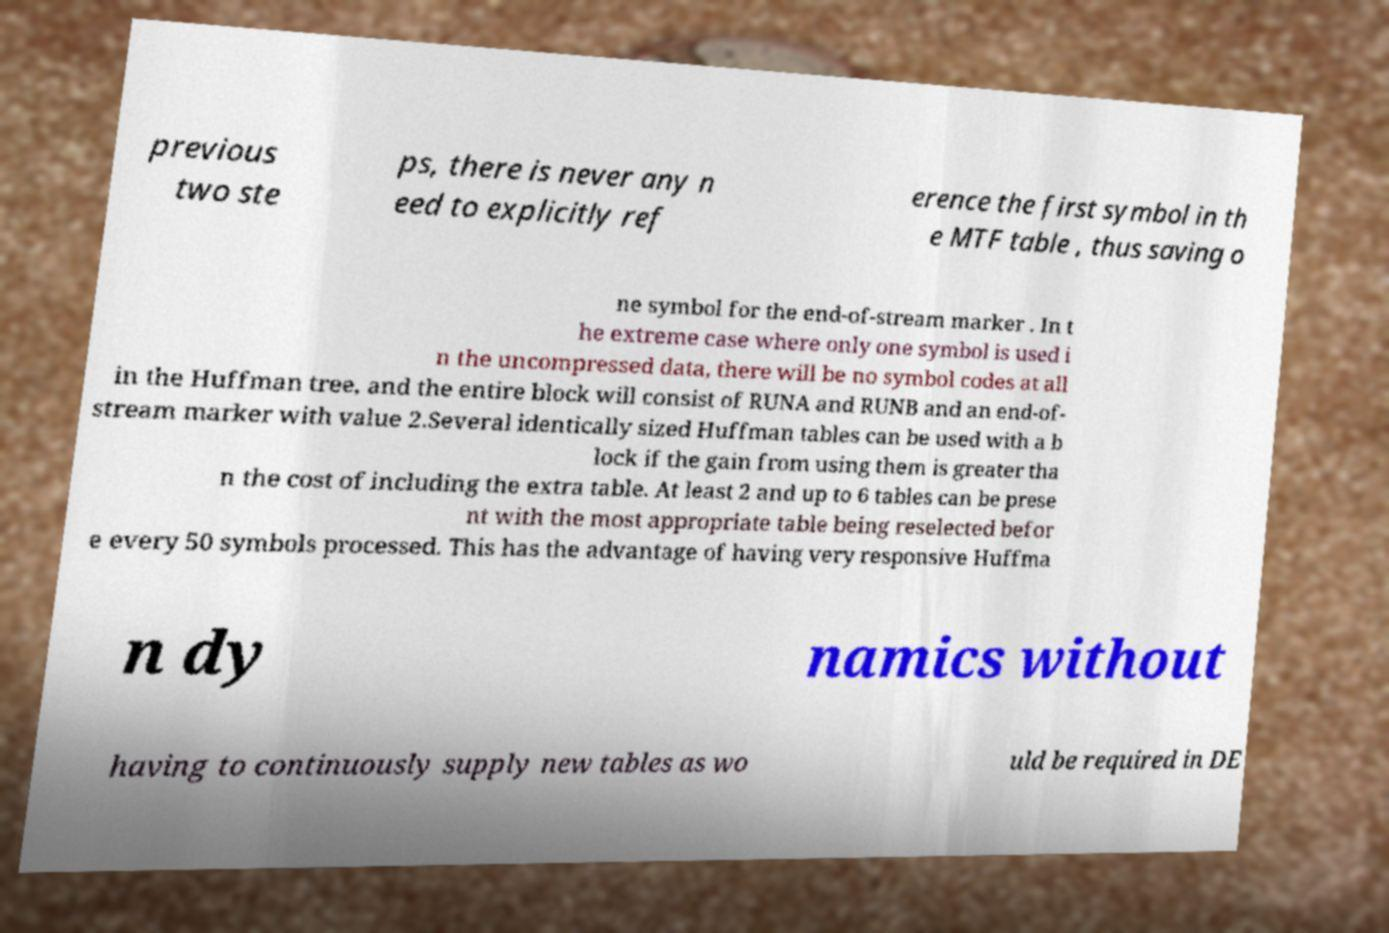For documentation purposes, I need the text within this image transcribed. Could you provide that? previous two ste ps, there is never any n eed to explicitly ref erence the first symbol in th e MTF table , thus saving o ne symbol for the end-of-stream marker . In t he extreme case where only one symbol is used i n the uncompressed data, there will be no symbol codes at all in the Huffman tree, and the entire block will consist of RUNA and RUNB and an end-of- stream marker with value 2.Several identically sized Huffman tables can be used with a b lock if the gain from using them is greater tha n the cost of including the extra table. At least 2 and up to 6 tables can be prese nt with the most appropriate table being reselected befor e every 50 symbols processed. This has the advantage of having very responsive Huffma n dy namics without having to continuously supply new tables as wo uld be required in DE 